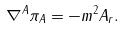Convert formula to latex. <formula><loc_0><loc_0><loc_500><loc_500>\nabla ^ { A } \pi _ { A } = - m ^ { 2 } A _ { r } .</formula> 